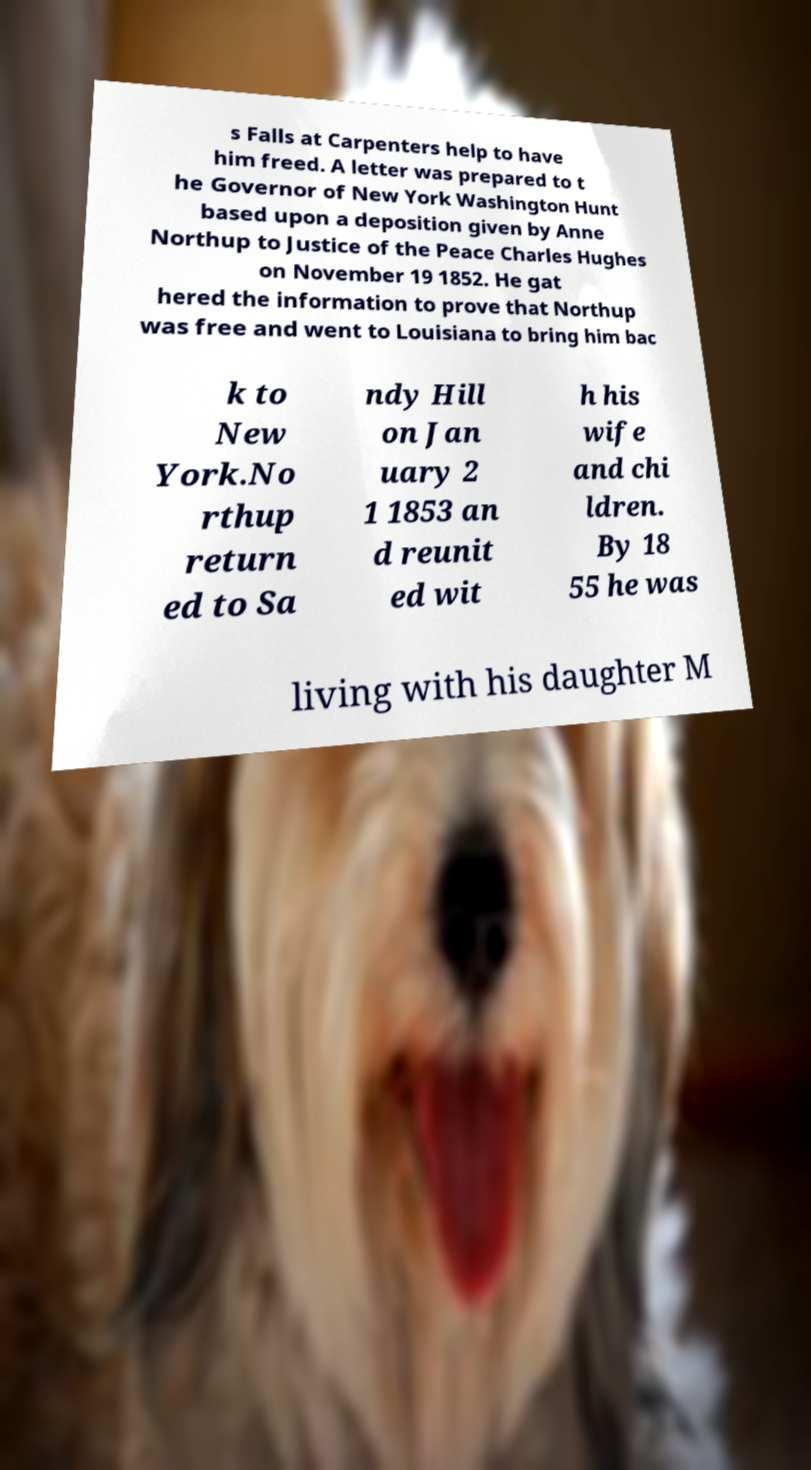Can you accurately transcribe the text from the provided image for me? s Falls at Carpenters help to have him freed. A letter was prepared to t he Governor of New York Washington Hunt based upon a deposition given by Anne Northup to Justice of the Peace Charles Hughes on November 19 1852. He gat hered the information to prove that Northup was free and went to Louisiana to bring him bac k to New York.No rthup return ed to Sa ndy Hill on Jan uary 2 1 1853 an d reunit ed wit h his wife and chi ldren. By 18 55 he was living with his daughter M 